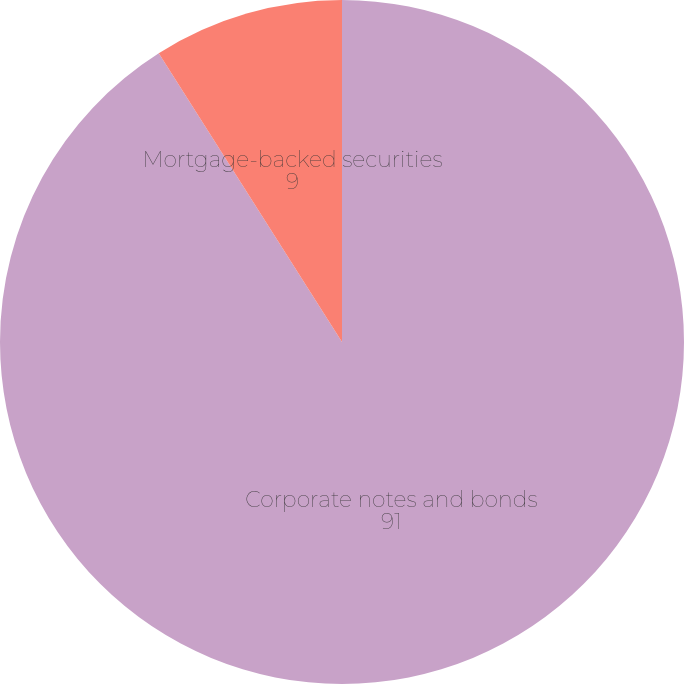<chart> <loc_0><loc_0><loc_500><loc_500><pie_chart><fcel>Corporate notes and bonds<fcel>Mortgage-backed securities<nl><fcel>91.0%<fcel>9.0%<nl></chart> 